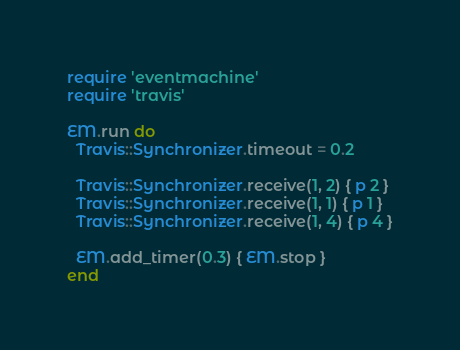Convert code to text. <code><loc_0><loc_0><loc_500><loc_500><_Ruby_>require 'eventmachine'
require 'travis'

EM.run do
  Travis::Synchronizer.timeout = 0.2

  Travis::Synchronizer.receive(1, 2) { p 2 }
  Travis::Synchronizer.receive(1, 1) { p 1 }
  Travis::Synchronizer.receive(1, 4) { p 4 }

  EM.add_timer(0.3) { EM.stop }
end

</code> 